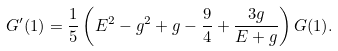Convert formula to latex. <formula><loc_0><loc_0><loc_500><loc_500>G ^ { \prime } ( 1 ) = \frac { 1 } { 5 } \left ( E ^ { 2 } - g ^ { 2 } + g - \frac { 9 } { 4 } + \frac { 3 g } { E + g } \right ) G ( 1 ) .</formula> 